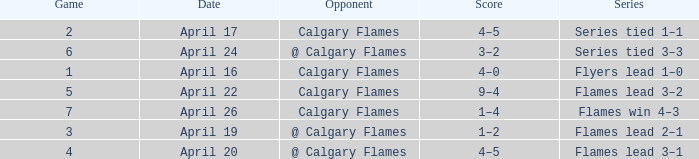Which Series has a Score of 9–4? Flames lead 3–2. 